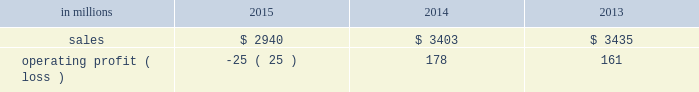Augusta , georgia mill and $ 2 million of costs associated with the sale of the shorewood business .
Consumer packaging .
North american consumer packaging net sales were $ 1.9 billion in 2015 compared with $ 2.0 billion in 2014 and $ 2.0 billion in 2013 .
Operating profits were $ 81 million ( $ 91 million excluding the cost associated with the planned conversion of our riegelwood mill to 100% ( 100 % ) pulp production , net of proceeds from the sale of the carolina coated bristols brand , and sheet plant closure costs ) in 2015 compared with $ 92 million ( $ 100 million excluding sheet plant closure costs ) in 2014 and $ 63 million ( $ 110 million excluding paper machine shutdown costs and costs related to the sale of the shorewood business ) in 2013 .
Coated paperboard sales volumes in 2015 were lower than in 2014 reflecting weaker market demand .
The business took about 77000 tons of market-related downtime in 2015 compared with about 41000 tons in 2014 .
Average sales price realizations increased modestly year over year as competitive pressures in the current year only partially offset the impact of sales price increases implemented in 2014 .
Input costs decreased for energy and chemicals , but wood costs increased .
Planned maintenance downtime costs were $ 10 million lower in 2015 .
Operating costs were higher , mainly due to inflation and overhead costs .
Foodservice sales volumes increased in 2015 compared with 2014 reflecting strong market demand .
Average sales margins increased due to lower resin costs and a more favorable mix .
Operating costs and distribution costs were both higher .
Looking ahead to the first quarter of 2016 , coated paperboard sales volumes are expected to be slightly lower than in the fourth quarter of 2015 due to our exit from the coated bristols market .
Average sales price realizations are expected to be flat , but margins should benefit from a more favorable product mix .
Input costs are expected to be higher for wood , chemicals and energy .
Planned maintenance downtime costs should be $ 4 million higher with a planned maintenance outage scheduled at our augusta mill in the first quarter .
Foodservice sales volumes are expected to be seasonally lower .
Average sales margins are expected to improve due to a more favorable mix .
Operating costs are expected to decrease .
European consumer packaging net sales in 2015 were $ 319 million compared with $ 365 million in 2014 and $ 380 million in 2013 .
Operating profits in 2015 were $ 87 million compared with $ 91 million in 2014 and $ 100 million in 2013 .
Sales volumes in 2015 compared with 2014 increased in europe , but decreased in russia .
Average sales margins improved in russia due to slightly higher average sales price realizations and a more favorable mix .
In europe average sales margins decreased reflecting lower average sales price realizations and an unfavorable mix .
Input costs were lower in europe , primarily for wood and energy , but were higher in russia , primarily for wood .
Looking forward to the first quarter of 2016 , compared with the fourth quarter of 2015 , sales volumes are expected to be stable .
Average sales price realizations are expected to be slightly higher in both russia and europe .
Input costs are expected to be flat , while operating costs are expected to increase .
Asian consumer packaging the company sold its 55% ( 55 % ) equity share in the ip-sun jv in october 2015 .
Net sales and operating profits presented below include results through september 30 , 2015 .
Net sales were $ 682 million in 2015 compared with $ 1.0 billion in 2014 and $ 1.1 billion in 2013 .
Operating profits in 2015 were a loss of $ 193 million ( a loss of $ 19 million excluding goodwill and other asset impairment costs ) compared with losses of $ 5 million in 2014 and $ 2 million in 2013 .
Sales volumes and average sales price realizations were lower in 2015 due to over-supplied market conditions and competitive pressures .
Average sales margins were also negatively impacted by a less favorable mix .
Input costs and freight costs were lower and operating costs also decreased .
On october 13 , 2015 , the company finalized the sale of its 55% ( 55 % ) interest in ip asia coated paperboard ( ip- sun jv ) business , within the company's consumer packaging segment , to its chinese coated board joint venture partner , shandong sun holding group co. , ltd .
For rmb 149 million ( approximately usd $ 23 million ) .
During the third quarter of 2015 , a determination was made that the current book value of the asset group exceeded its estimated fair value of $ 23 million , which was the agreed upon selling price .
The 2015 loss includes the net pre-tax impairment charge of $ 174 million ( $ 113 million after taxes ) .
A pre-tax charge of $ 186 million was recorded during the third quarter in the company's consumer packaging segment to write down the long-lived assets of this business to their estimated fair value .
In the fourth quarter of 2015 , upon the sale and corresponding deconsolidation of ip-sun jv from the company's consolidated balance sheet , final adjustments were made resulting in a reduction of the impairment of $ 12 million .
The amount of pre-tax losses related to noncontrolling interest of the ip-sun jv included in the company's consolidated statement of operations for the years ended december 31 , 2015 , 2014 and 2013 were $ 19 million , $ 12 million and $ 8 million , respectively .
The amount of pre-tax losses related to the ip-sun jv included in the company's .
What was the change in net sales in 2015 in millions? 
Computations: (682 - 1000)
Answer: -318.0. 